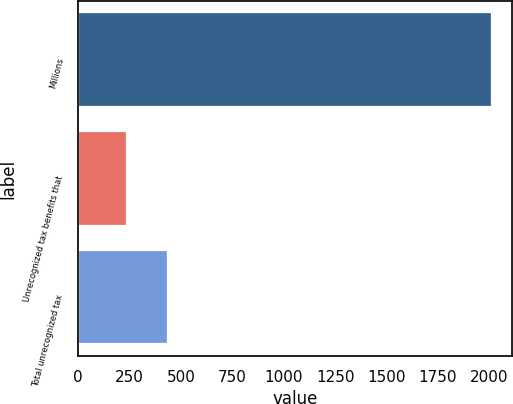<chart> <loc_0><loc_0><loc_500><loc_500><bar_chart><fcel>Millions<fcel>Unrecognized tax benefits that<fcel>Total unrecognized tax<nl><fcel>2012<fcel>238.1<fcel>435.2<nl></chart> 